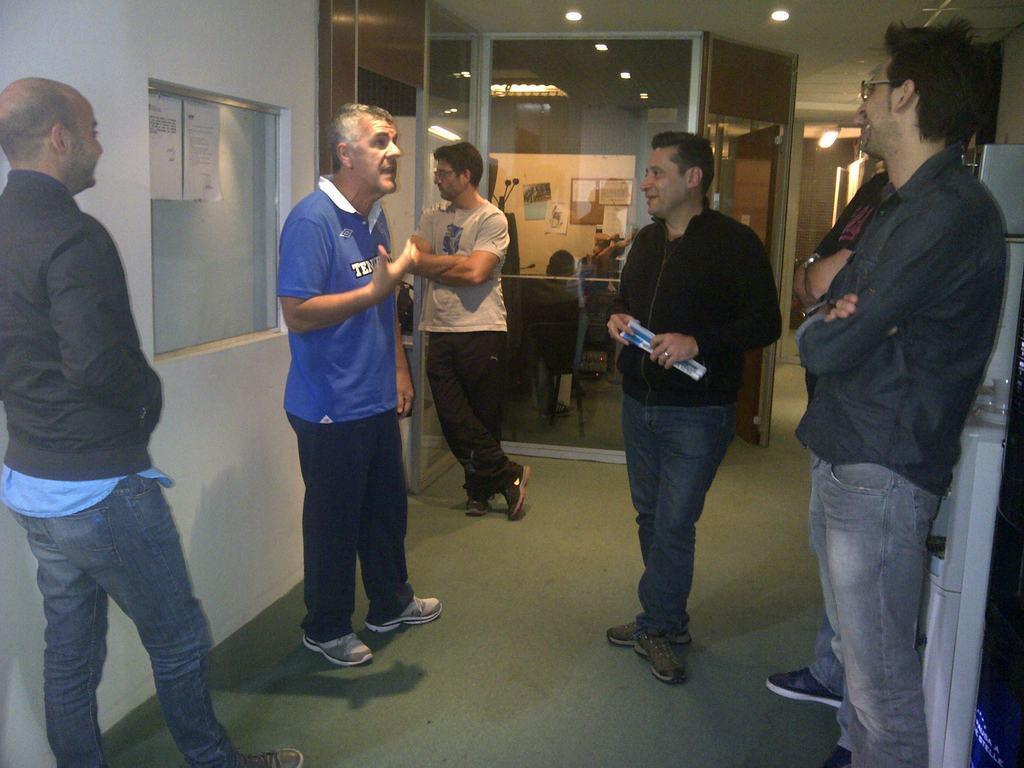In one or two sentences, can you explain what this image depicts? In the center of the image there are people standing. In the background of the image there is a glass cabin. To the left side of the image there is wall. At the bottom of the image there is carpet. At the top of the image there is ceiling with lights. 